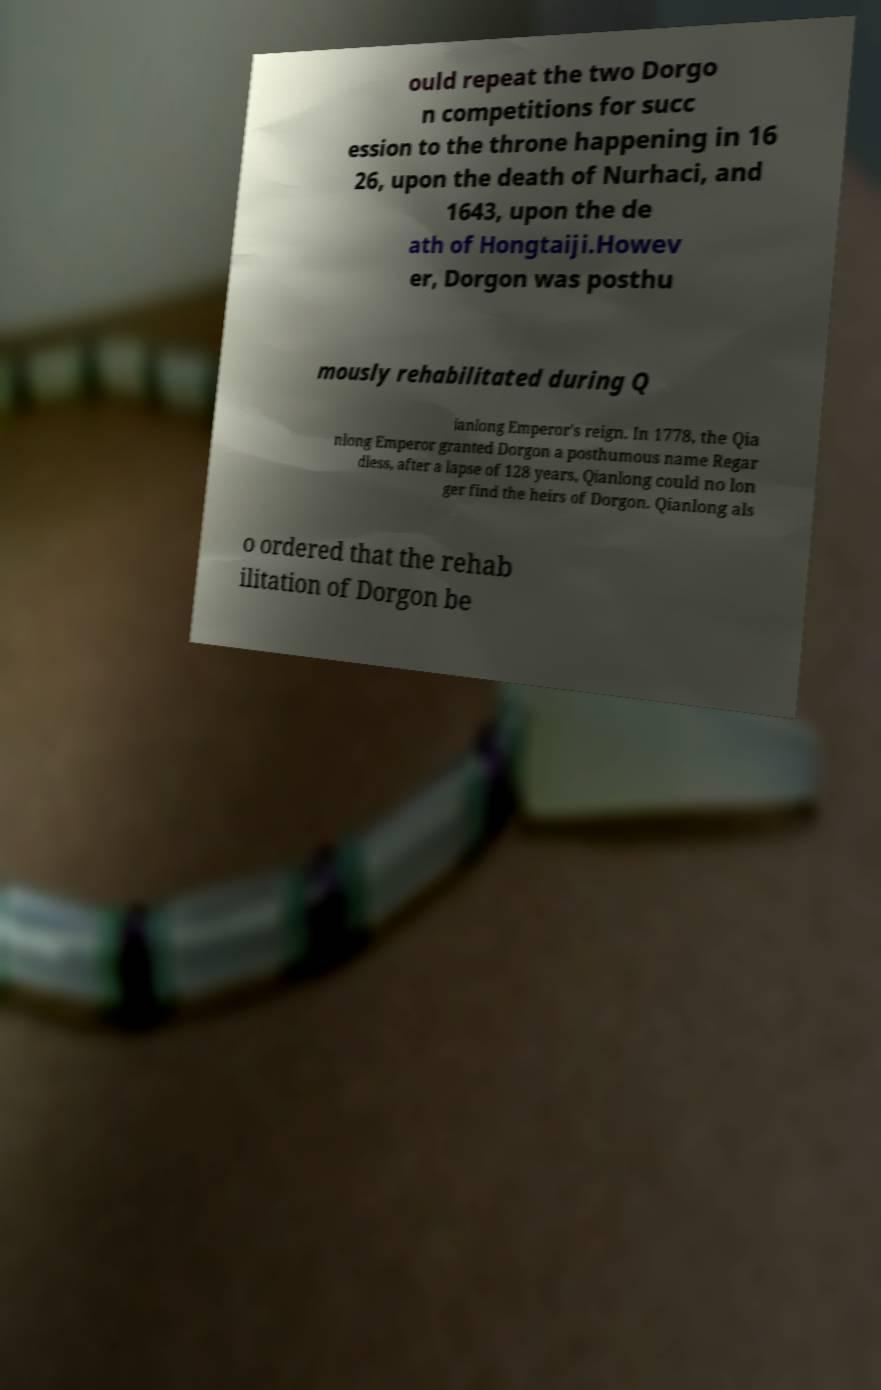Could you assist in decoding the text presented in this image and type it out clearly? ould repeat the two Dorgo n competitions for succ ession to the throne happening in 16 26, upon the death of Nurhaci, and 1643, upon the de ath of Hongtaiji.Howev er, Dorgon was posthu mously rehabilitated during Q ianlong Emperor's reign. In 1778, the Qia nlong Emperor granted Dorgon a posthumous name Regar dless, after a lapse of 128 years, Qianlong could no lon ger find the heirs of Dorgon. Qianlong als o ordered that the rehab ilitation of Dorgon be 